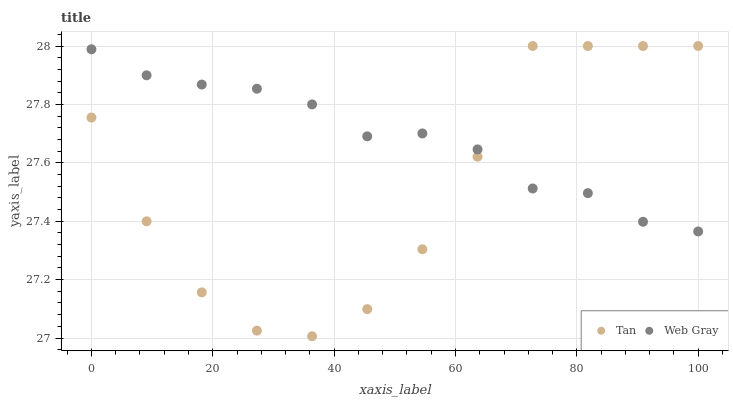Does Tan have the minimum area under the curve?
Answer yes or no. Yes. Does Web Gray have the maximum area under the curve?
Answer yes or no. Yes. Does Web Gray have the minimum area under the curve?
Answer yes or no. No. Is Web Gray the smoothest?
Answer yes or no. Yes. Is Tan the roughest?
Answer yes or no. Yes. Is Web Gray the roughest?
Answer yes or no. No. Does Tan have the lowest value?
Answer yes or no. Yes. Does Web Gray have the lowest value?
Answer yes or no. No. Does Tan have the highest value?
Answer yes or no. Yes. Does Web Gray have the highest value?
Answer yes or no. No. Does Tan intersect Web Gray?
Answer yes or no. Yes. Is Tan less than Web Gray?
Answer yes or no. No. Is Tan greater than Web Gray?
Answer yes or no. No. 